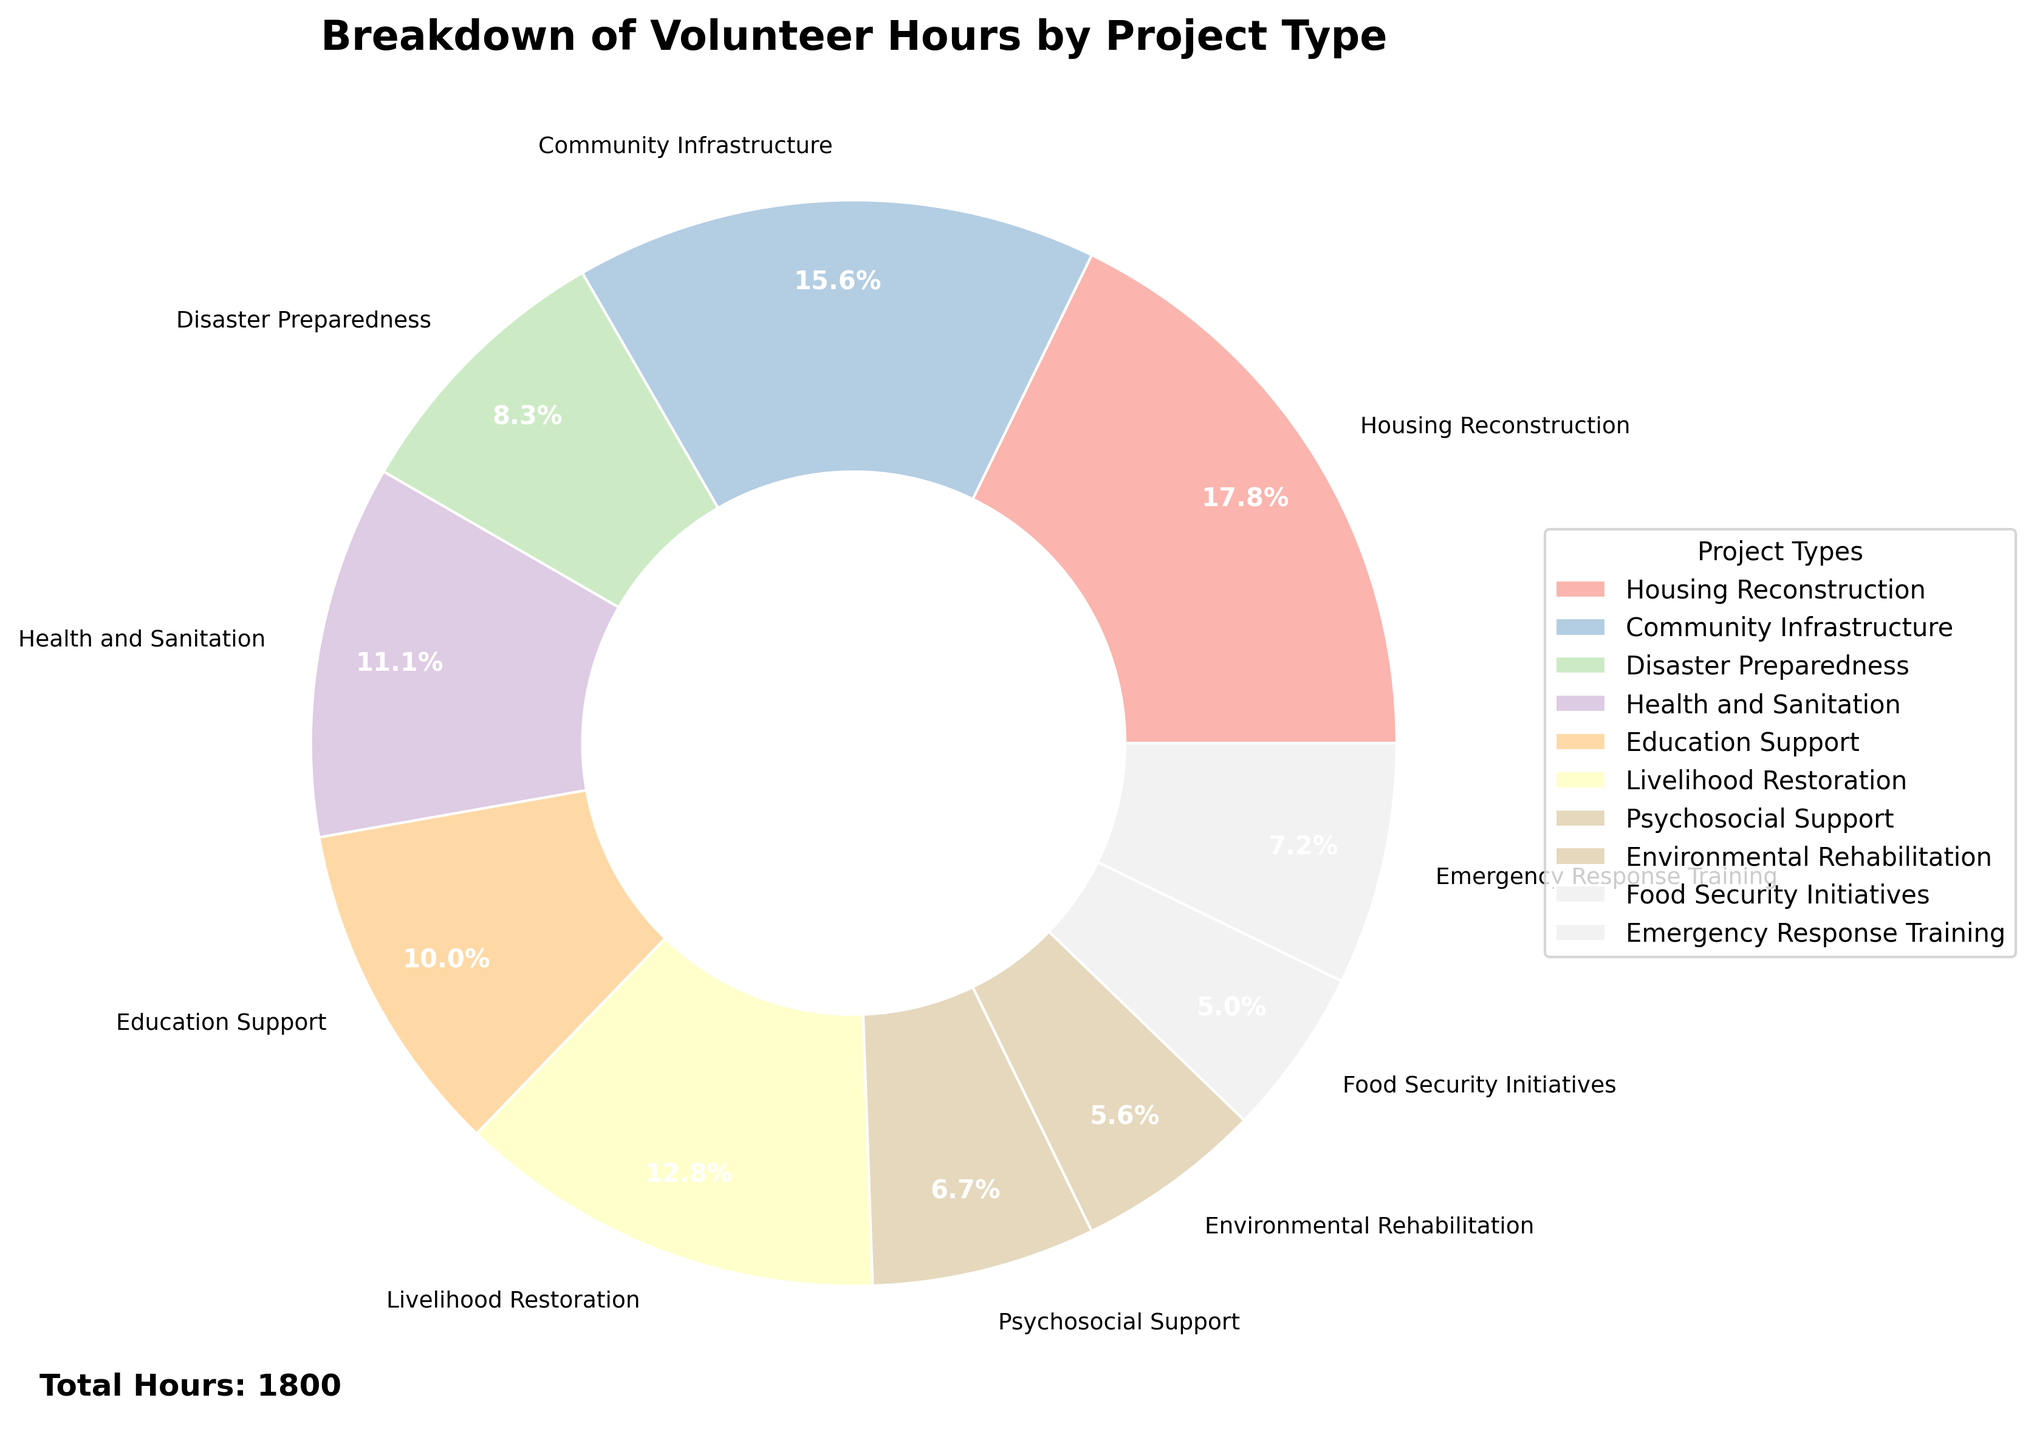What is the project type with the highest number of volunteer hours? The segment with the largest portion corresponds to Housing Reconstruction. The label shows Housing Reconstruction has 320 hours, which is the highest among all.
Answer: Housing Reconstruction How many more hours does Education Support have compared to Psychosocial Support? Education Support has 180 hours while Psychosocial Support has 120 hours. The difference is 180 - 120 = 60 hours.
Answer: 60 Which project type accounts for the smallest percentage of volunteer hours? The segment corresponding to Food Security Initiatives is the smallest. The label shows it has 90 hours, which is the smallest number of hours.
Answer: Food Security Initiatives How many project types have more than 200 volunteer hours? The pie chart shows that Housing Reconstruction (320), Community Infrastructure (280), and Livelihood Restoration (230) each have more than 200 hours. Counting these gives 3 project types.
Answer: 3 What is the total number of hours spent on Environmental Rehabilitation and Emergency Response Training combined? Environmental Rehabilitation and Emergency Response Training have 100 and 130 hours respectively. Adding them up gives 100 + 130 = 230 hours.
Answer: 230 What percentage of volunteer hours is spent on Disaster Preparedness? The Disaster Preparedness segment shows 150 hours. To find the percentage: (150 / Total Hours) * 100. Total Hours = 320 + 280 + 150 + 200 + 180 + 230 + 120 + 100 + 90 + 130 = 1800. Thus, (150 / 1800) * 100 ≈ 8.3%.
Answer: 8.3% Which project type has a percentage closest to 15%? From the chart, Health and Sanitation has 200 hours. (200 / 1800) * 100 = 11.1%, and Livelihood Restoration has 230 hours. (230 / 1800) * 100 = 12.8%. Both these values are relatively close to 15% but less than it.
Answer: Livelihood Restoration How does the percentage of hours for Community Infrastructure compare to that of Housing Reconstruction? Community Infrastructure has 280 hours and Housing Reconstruction has 320 hours. Their percentages are respectively (280 / 1800) * 100 ≈ 15.6% and (320 / 1800) * 100 ≈ 17.8%. Housing Reconstruction has a higher percentage.
Answer: Housing Reconstruction has a higher percentage What is the combined percentage of hours for Health and Sanitation and Education Support? Health and Sanitation has 200 hours and Education Support has 180 hours. Total hours = 200 + 180 = 380. Percentage = (380 / 1800) * 100 ≈ 21.1%.
Answer: 21.1% 